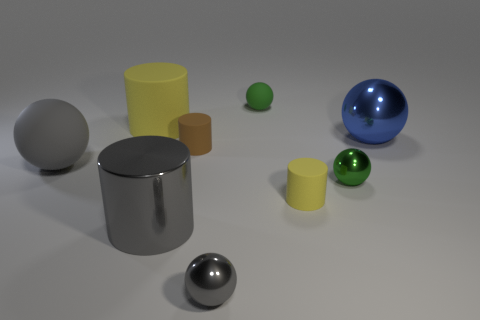Subtract all blue balls. How many balls are left? 4 Subtract all green shiny spheres. How many spheres are left? 4 Subtract all red cylinders. Subtract all red blocks. How many cylinders are left? 4 Subtract all cylinders. How many objects are left? 5 Subtract all yellow rubber things. Subtract all tiny brown rubber objects. How many objects are left? 6 Add 3 green objects. How many green objects are left? 5 Add 1 yellow rubber things. How many yellow rubber things exist? 3 Subtract 1 blue spheres. How many objects are left? 8 